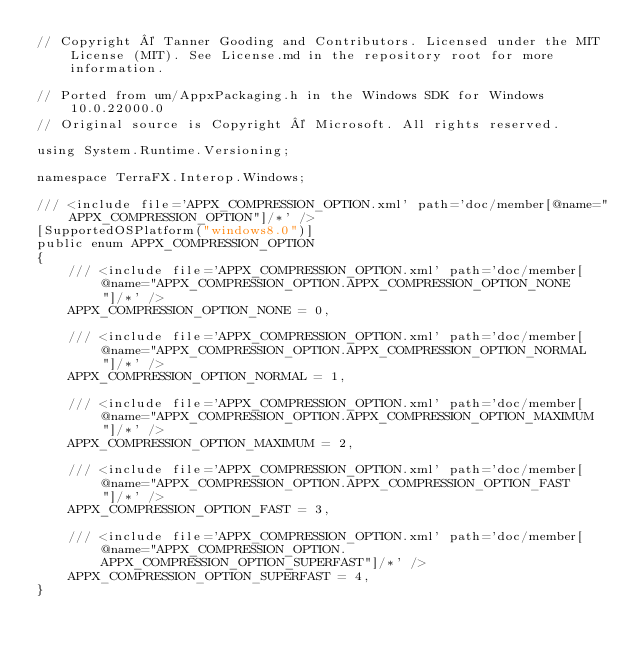<code> <loc_0><loc_0><loc_500><loc_500><_C#_>// Copyright © Tanner Gooding and Contributors. Licensed under the MIT License (MIT). See License.md in the repository root for more information.

// Ported from um/AppxPackaging.h in the Windows SDK for Windows 10.0.22000.0
// Original source is Copyright © Microsoft. All rights reserved.

using System.Runtime.Versioning;

namespace TerraFX.Interop.Windows;

/// <include file='APPX_COMPRESSION_OPTION.xml' path='doc/member[@name="APPX_COMPRESSION_OPTION"]/*' />
[SupportedOSPlatform("windows8.0")]
public enum APPX_COMPRESSION_OPTION
{
    /// <include file='APPX_COMPRESSION_OPTION.xml' path='doc/member[@name="APPX_COMPRESSION_OPTION.APPX_COMPRESSION_OPTION_NONE"]/*' />
    APPX_COMPRESSION_OPTION_NONE = 0,

    /// <include file='APPX_COMPRESSION_OPTION.xml' path='doc/member[@name="APPX_COMPRESSION_OPTION.APPX_COMPRESSION_OPTION_NORMAL"]/*' />
    APPX_COMPRESSION_OPTION_NORMAL = 1,

    /// <include file='APPX_COMPRESSION_OPTION.xml' path='doc/member[@name="APPX_COMPRESSION_OPTION.APPX_COMPRESSION_OPTION_MAXIMUM"]/*' />
    APPX_COMPRESSION_OPTION_MAXIMUM = 2,

    /// <include file='APPX_COMPRESSION_OPTION.xml' path='doc/member[@name="APPX_COMPRESSION_OPTION.APPX_COMPRESSION_OPTION_FAST"]/*' />
    APPX_COMPRESSION_OPTION_FAST = 3,

    /// <include file='APPX_COMPRESSION_OPTION.xml' path='doc/member[@name="APPX_COMPRESSION_OPTION.APPX_COMPRESSION_OPTION_SUPERFAST"]/*' />
    APPX_COMPRESSION_OPTION_SUPERFAST = 4,
}
</code> 